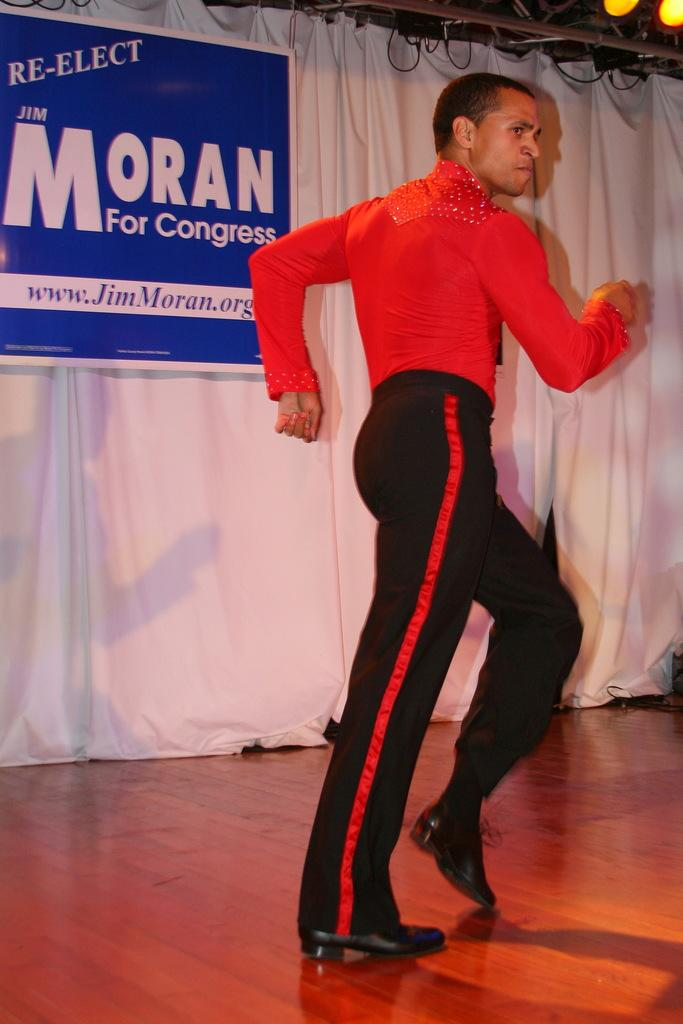What is the main subject of the image? There is a person in the image. What is the person doing in the image? The person is dancing on a stage. What is located behind the person on the stage? There is a curtain behind the person. Is there any additional information on the curtain? Yes, there is a banner on the curtain. How does the person in the image express their pain while dancing? There is no indication of pain in the image; the person is dancing on a stage. 